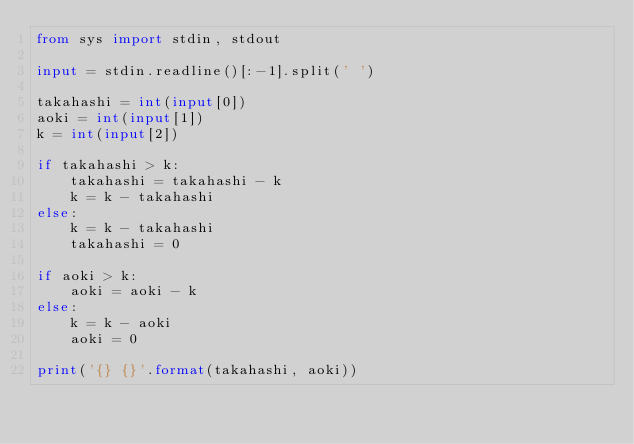<code> <loc_0><loc_0><loc_500><loc_500><_Python_>from sys import stdin, stdout

input = stdin.readline()[:-1].split(' ')

takahashi = int(input[0])
aoki = int(input[1])
k = int(input[2])

if takahashi > k:
    takahashi = takahashi - k
    k = k - takahashi
else:
    k = k - takahashi
    takahashi = 0

if aoki > k:
    aoki = aoki - k
else:
    k = k - aoki
    aoki = 0

print('{} {}'.format(takahashi, aoki))
</code> 